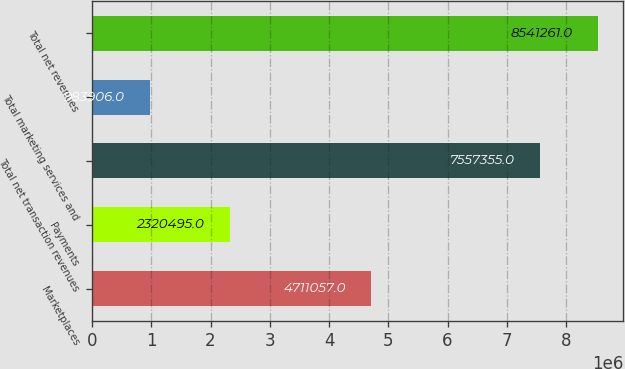Convert chart to OTSL. <chart><loc_0><loc_0><loc_500><loc_500><bar_chart><fcel>Marketplaces<fcel>Payments<fcel>Total net transaction revenues<fcel>Total marketing services and<fcel>Total net revenues<nl><fcel>4.71106e+06<fcel>2.3205e+06<fcel>7.55736e+06<fcel>983906<fcel>8.54126e+06<nl></chart> 